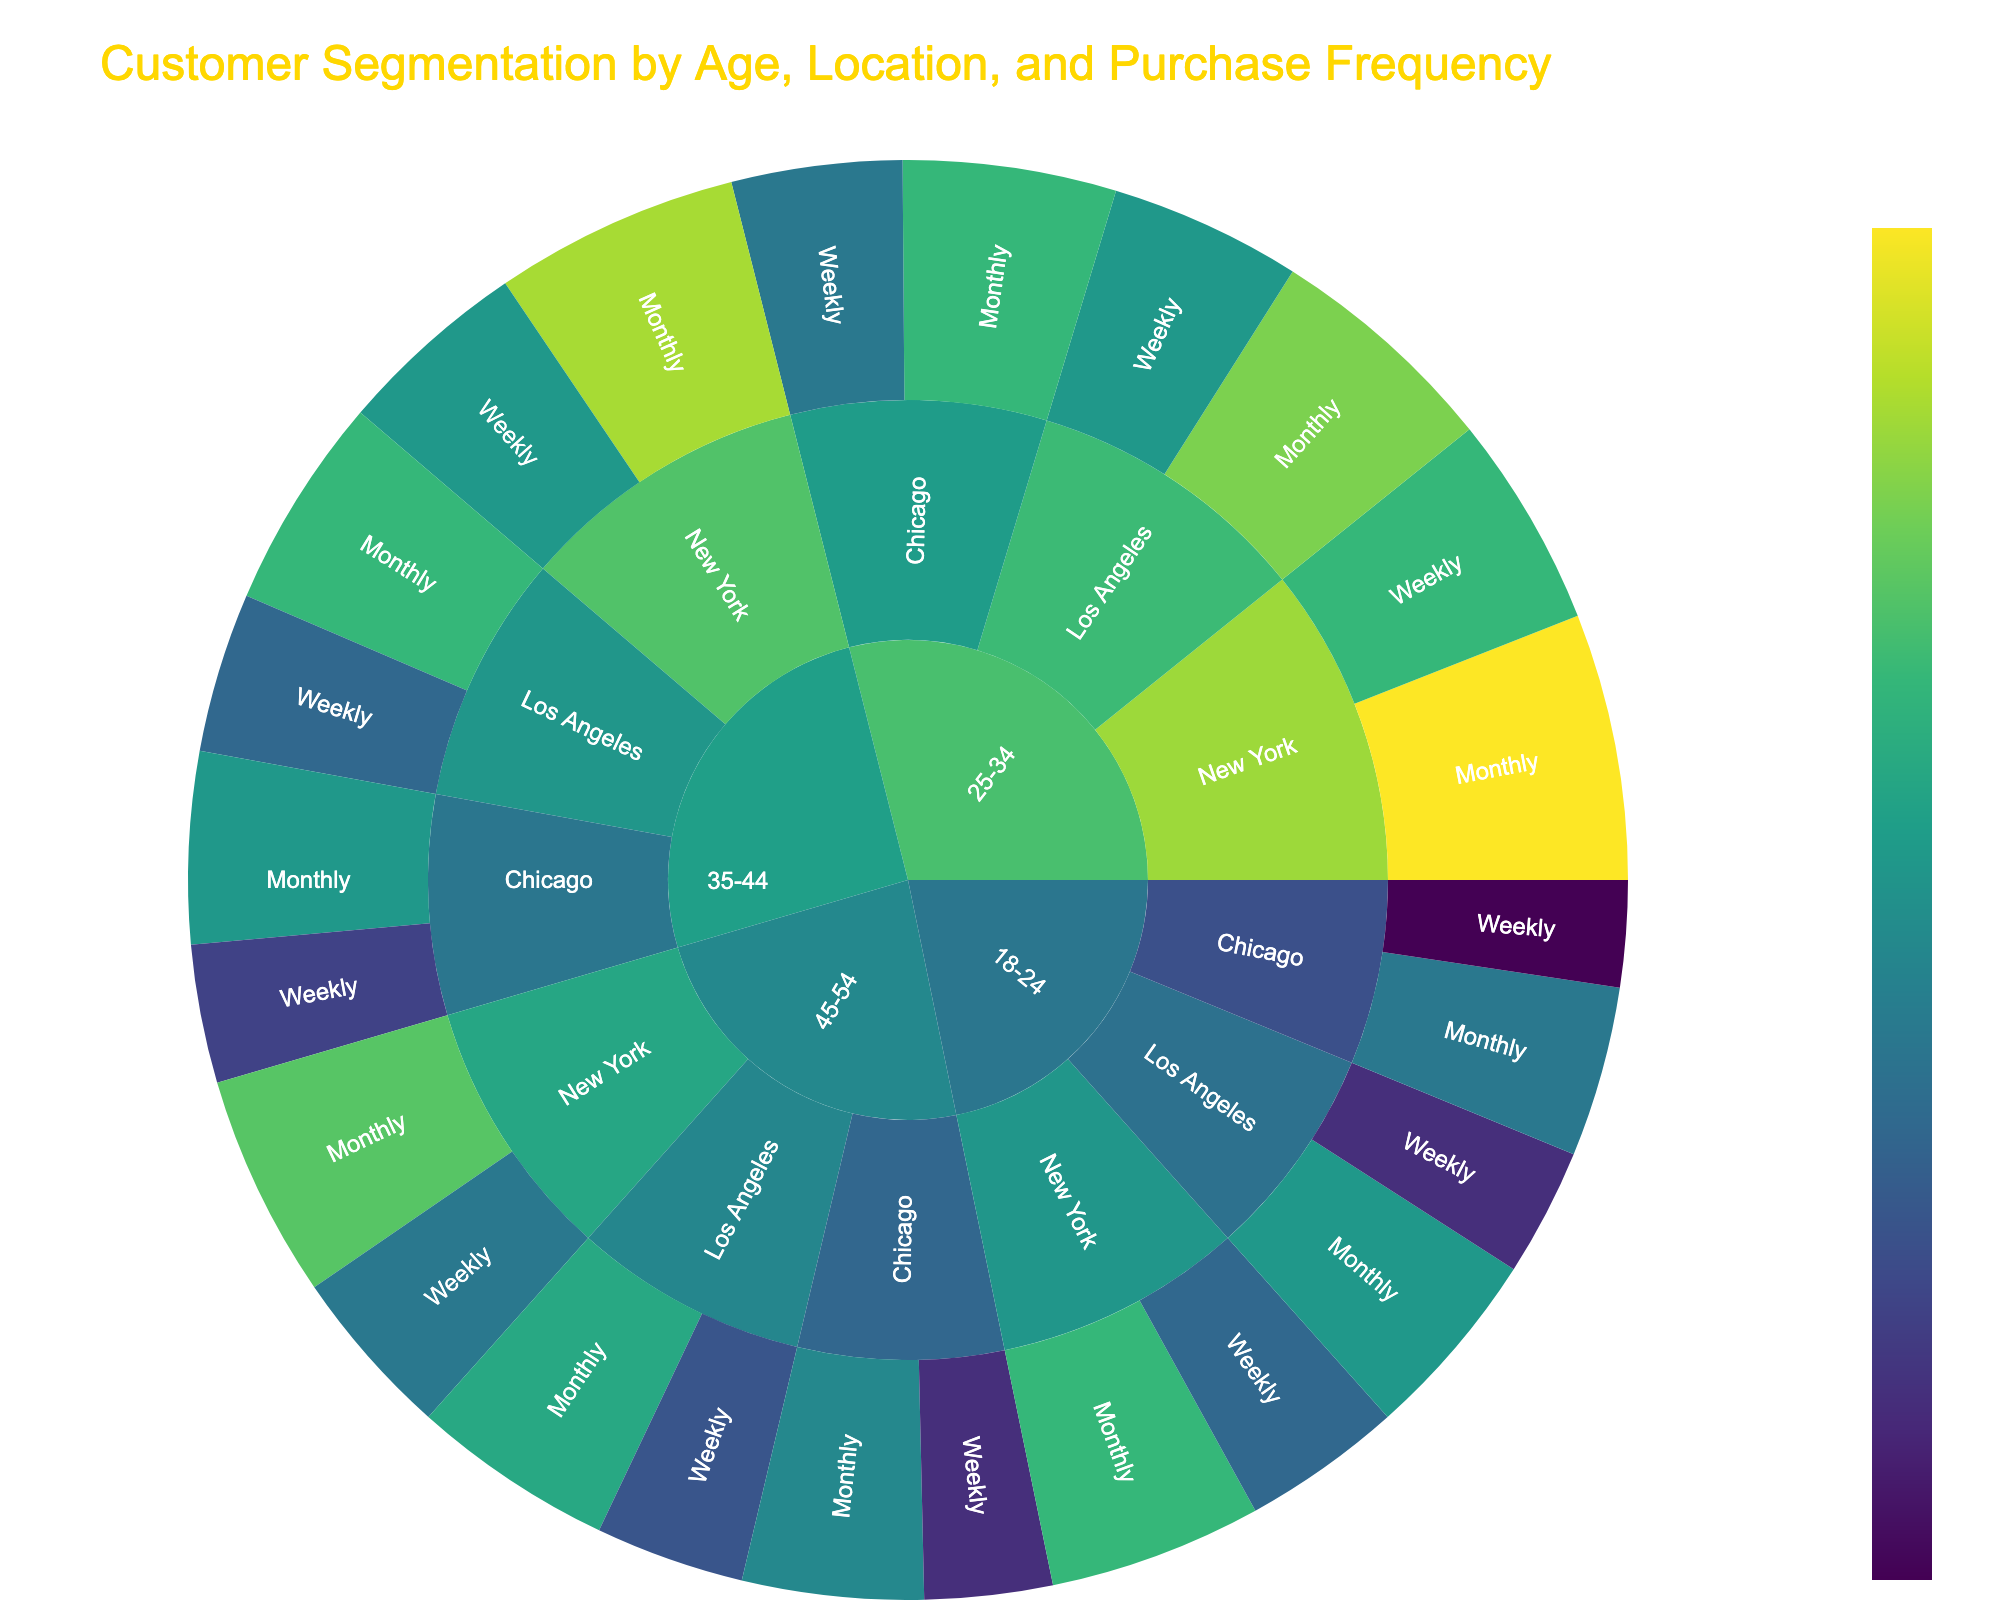What is the title of the Sunburst Plot? The title is displayed at the top of the plot. It is "Customer Segmentation by Age, Location, and Purchase Frequency."
Answer: Customer Segmentation by Age, Location, and Purchase Frequency Which age group has the highest total value? Sum the values for each age group. For 25-34: (200+250+180+220+160+200) = 1210. Compare this sum with other age groups. 25-34 has the highest value with 1210.
Answer: 25-34 Which purchase frequency in New York for age group 18-24 has the higher value? Compare the values for Weekly (150) and Monthly (200) purchases in New York within the 18-24 age group. Monthly is greater than Weekly.
Answer: Monthly What is the total value for Chicago across all age groups? Sum the values for Chicago across all age groups: (100+160+160+200+130+180+120+170) = 1220.
Answer: 1220 How does the value for Monthly purchases in Los Angeles for the 35-44 age group compare to the same category in New York? For Los Angeles 35-44 Monthly is 200; for New York is 230. Compare 200 to 230. 200 is less than 230.
Answer: Less Which location has the highest value for Weekly purchases for the 25-34 age group? Compare Weekly purchases in New York (200), Los Angeles (180), Chicago (160) for the 25-34 age group. New York has the highest value.
Answer: New York What is the value difference between Weekly and Monthly purchases in Chicago for the 45-54 age group? Subtract the Weekly value (120) from the Monthly value (170) in Chicago for 45-54 age group. 170 - 120 = 50.
Answer: 50 Which age group has the most even distribution between New York and Los Angeles for Monthly purchases? Compare Monthly values in New York and Los Angeles for each age group and find the smallest difference. For 25-34 the difference is
Answer: 25-34 